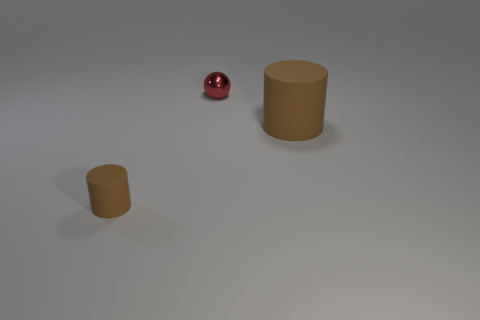What number of cylinders are to the left of the rubber cylinder that is behind the brown cylinder that is in front of the large rubber object?
Keep it short and to the point. 1. Is the shape of the tiny brown object the same as the small metallic object?
Your response must be concise. No. Is the small thing in front of the big matte cylinder made of the same material as the brown cylinder that is on the right side of the tiny brown rubber object?
Your response must be concise. Yes. What number of things are either big brown cylinders in front of the tiny red thing or cylinders that are on the left side of the large brown cylinder?
Your answer should be compact. 2. Is there any other thing that is the same shape as the shiny object?
Your answer should be compact. No. What number of tiny brown rubber cylinders are there?
Your answer should be very brief. 1. Is there a cyan shiny object that has the same size as the red shiny ball?
Provide a succinct answer. No. Do the large brown cylinder and the brown thing left of the red metal object have the same material?
Your response must be concise. Yes. There is a tiny red ball that is to the left of the big cylinder; what is its material?
Your response must be concise. Metal. The red thing is what size?
Provide a succinct answer. Small. 